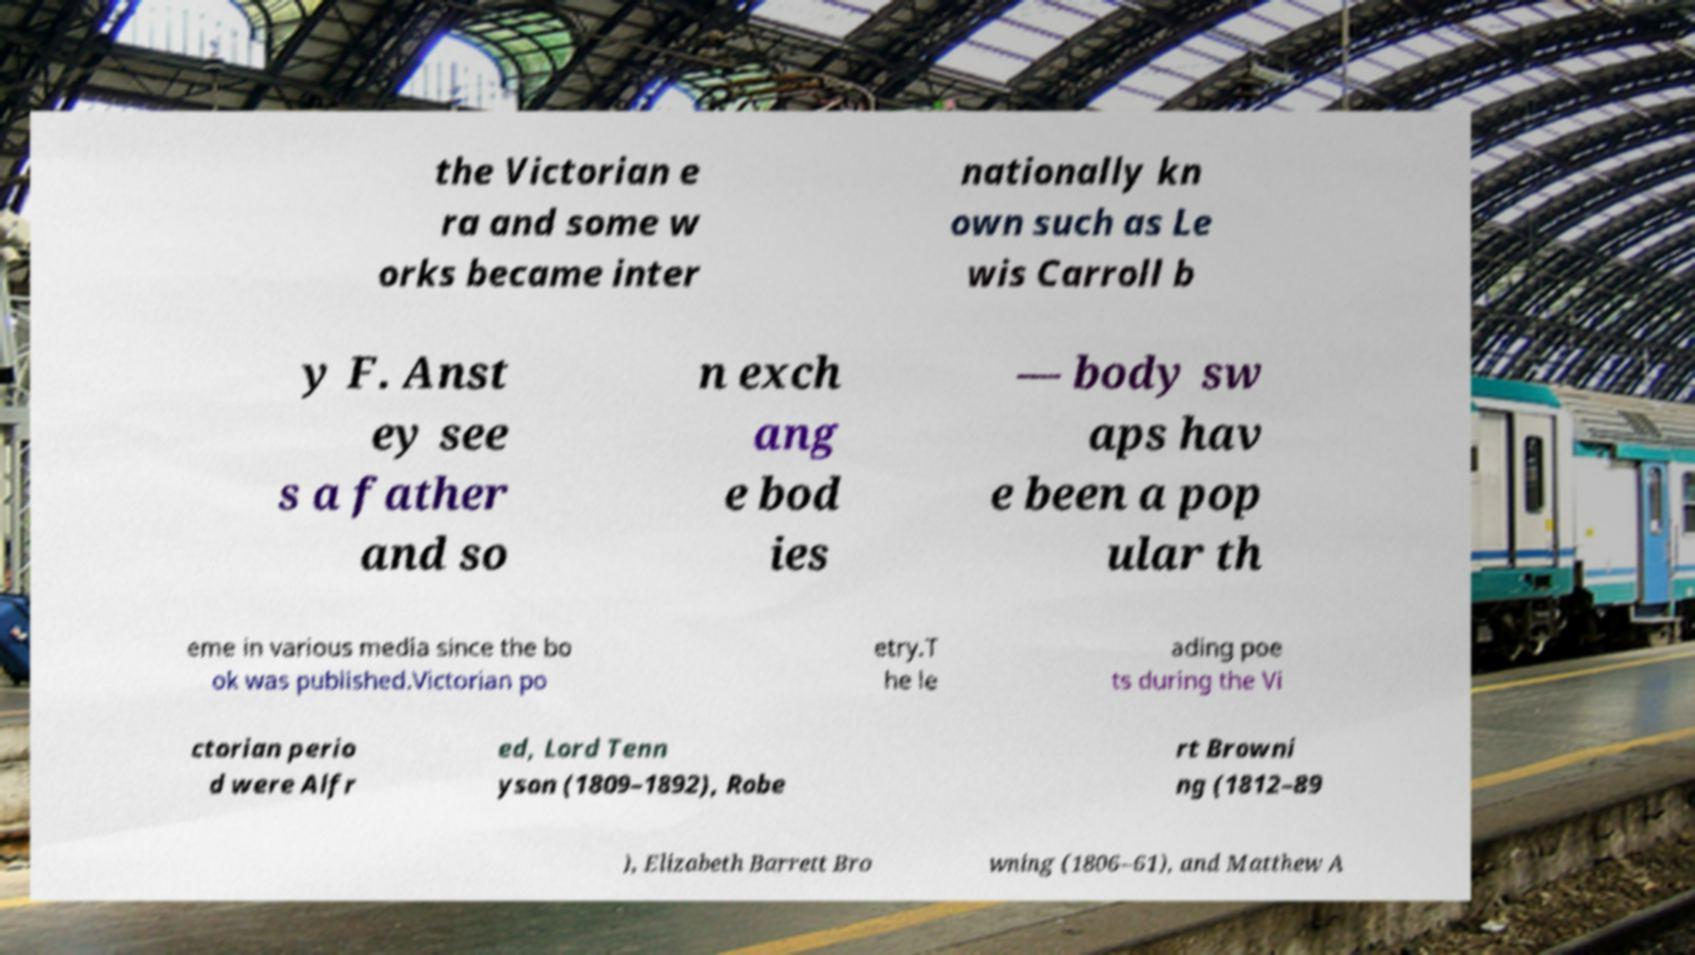For documentation purposes, I need the text within this image transcribed. Could you provide that? the Victorian e ra and some w orks became inter nationally kn own such as Le wis Carroll b y F. Anst ey see s a father and so n exch ang e bod ies — body sw aps hav e been a pop ular th eme in various media since the bo ok was published.Victorian po etry.T he le ading poe ts during the Vi ctorian perio d were Alfr ed, Lord Tenn yson (1809–1892), Robe rt Browni ng (1812–89 ), Elizabeth Barrett Bro wning (1806–61), and Matthew A 